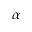<formula> <loc_0><loc_0><loc_500><loc_500>\alpha</formula> 